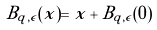<formula> <loc_0><loc_0><loc_500><loc_500>B _ { q , \epsilon } ( x ) = x + B _ { q , \epsilon } ( 0 )</formula> 